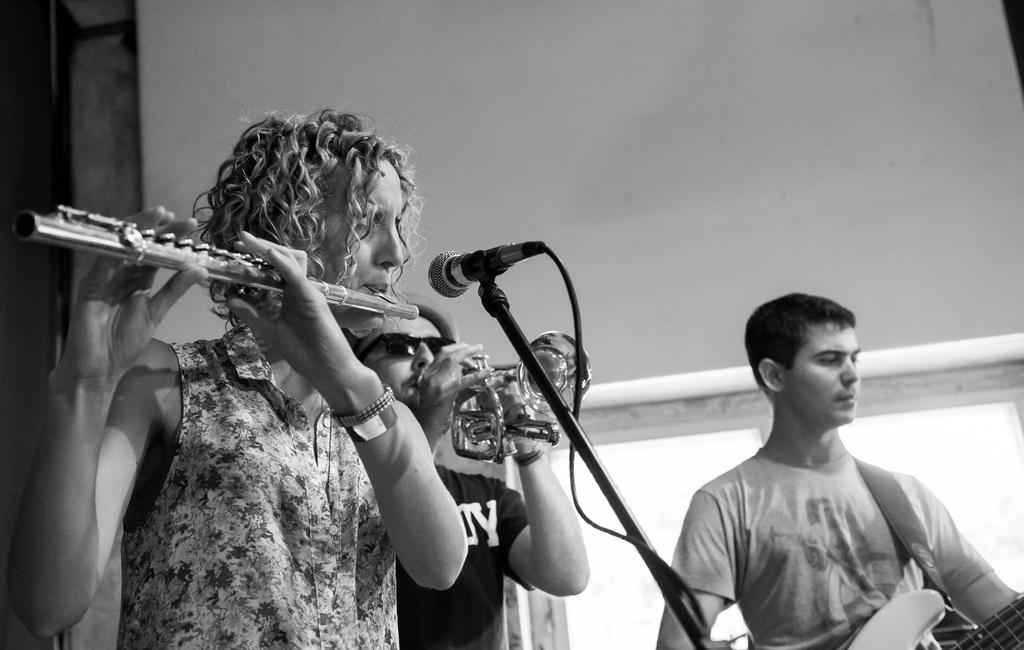What is the woman in the image doing? The woman is playing the flute in the image. What object is present that might be used for amplifying sound? There is a microphone in the image. How many men are in the image? There are two men in the image. What are the men doing in the image? The men are playing music instruments in the image. What type of house is visible in the image? There is no house present in the image. At what angle is the woman holding the flute in the image? The angle at which the woman is holding the flute cannot be determined from the image. 